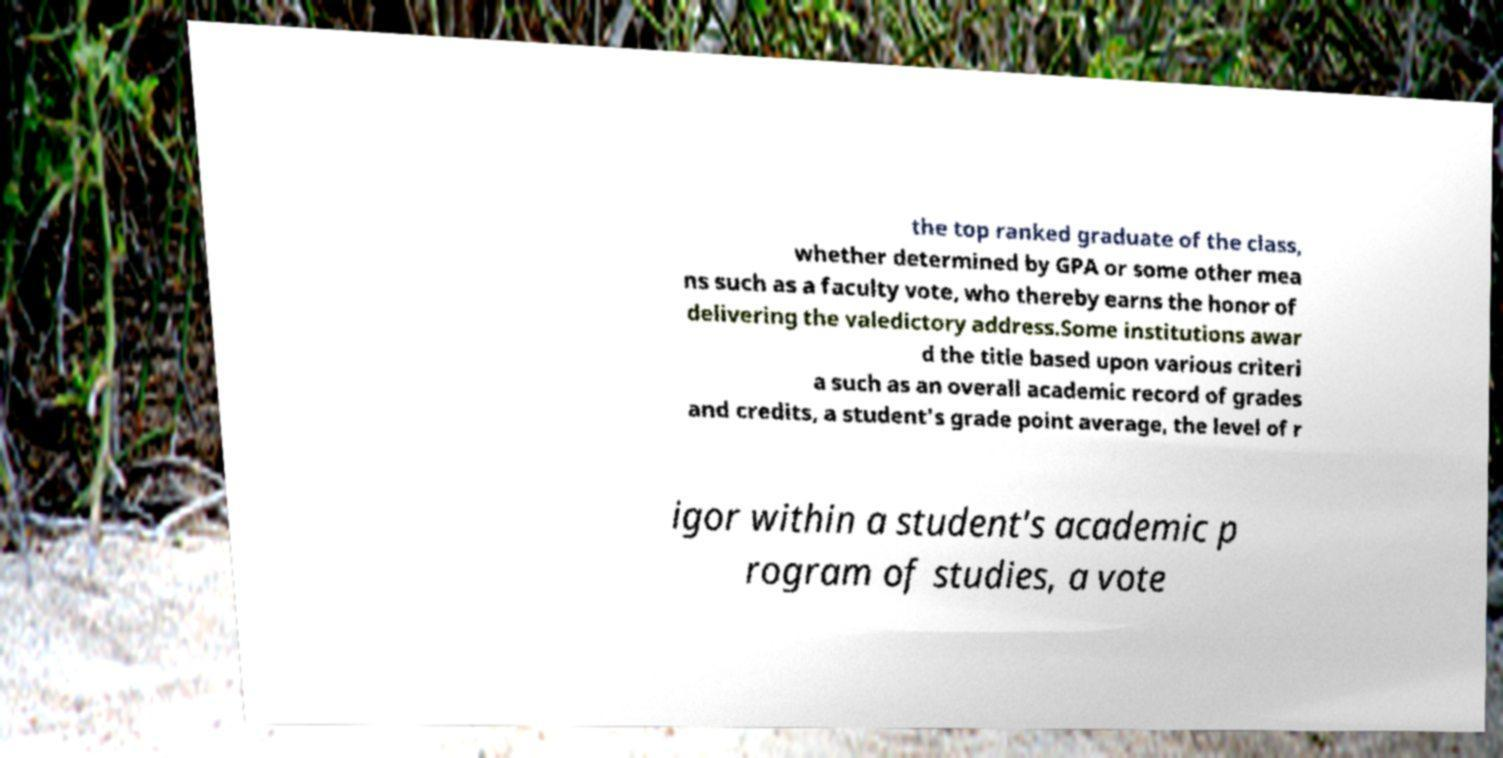Could you extract and type out the text from this image? the top ranked graduate of the class, whether determined by GPA or some other mea ns such as a faculty vote, who thereby earns the honor of delivering the valedictory address.Some institutions awar d the title based upon various criteri a such as an overall academic record of grades and credits, a student's grade point average, the level of r igor within a student's academic p rogram of studies, a vote 